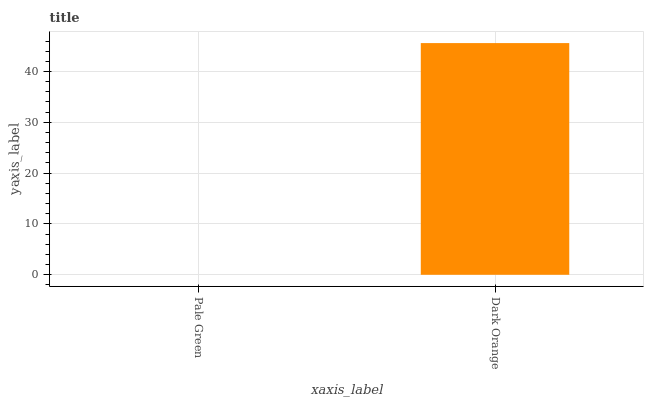Is Pale Green the minimum?
Answer yes or no. Yes. Is Dark Orange the maximum?
Answer yes or no. Yes. Is Dark Orange the minimum?
Answer yes or no. No. Is Dark Orange greater than Pale Green?
Answer yes or no. Yes. Is Pale Green less than Dark Orange?
Answer yes or no. Yes. Is Pale Green greater than Dark Orange?
Answer yes or no. No. Is Dark Orange less than Pale Green?
Answer yes or no. No. Is Dark Orange the high median?
Answer yes or no. Yes. Is Pale Green the low median?
Answer yes or no. Yes. Is Pale Green the high median?
Answer yes or no. No. Is Dark Orange the low median?
Answer yes or no. No. 